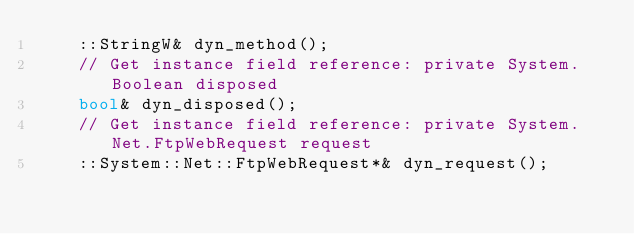<code> <loc_0><loc_0><loc_500><loc_500><_C++_>    ::StringW& dyn_method();
    // Get instance field reference: private System.Boolean disposed
    bool& dyn_disposed();
    // Get instance field reference: private System.Net.FtpWebRequest request
    ::System::Net::FtpWebRequest*& dyn_request();</code> 